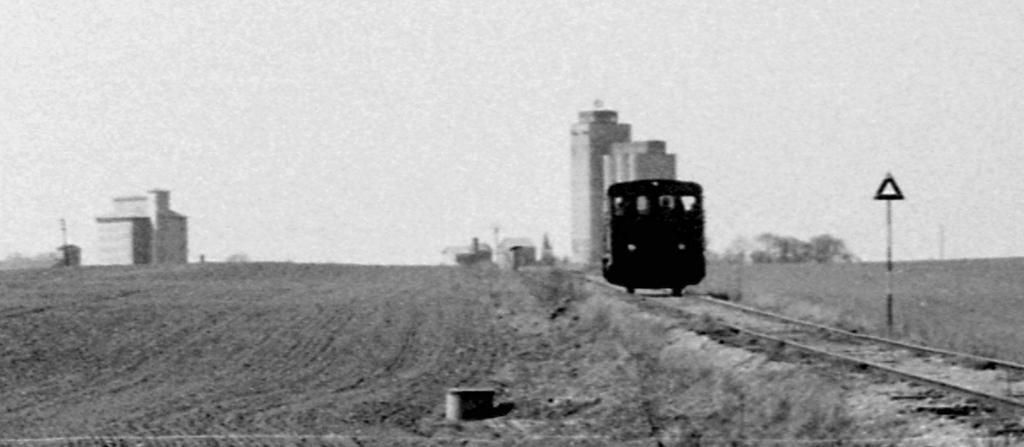Please provide a concise description of this image. This is a black and white picture, in the middle there is a train going on the track, in the back there are buildings and above its sky. 